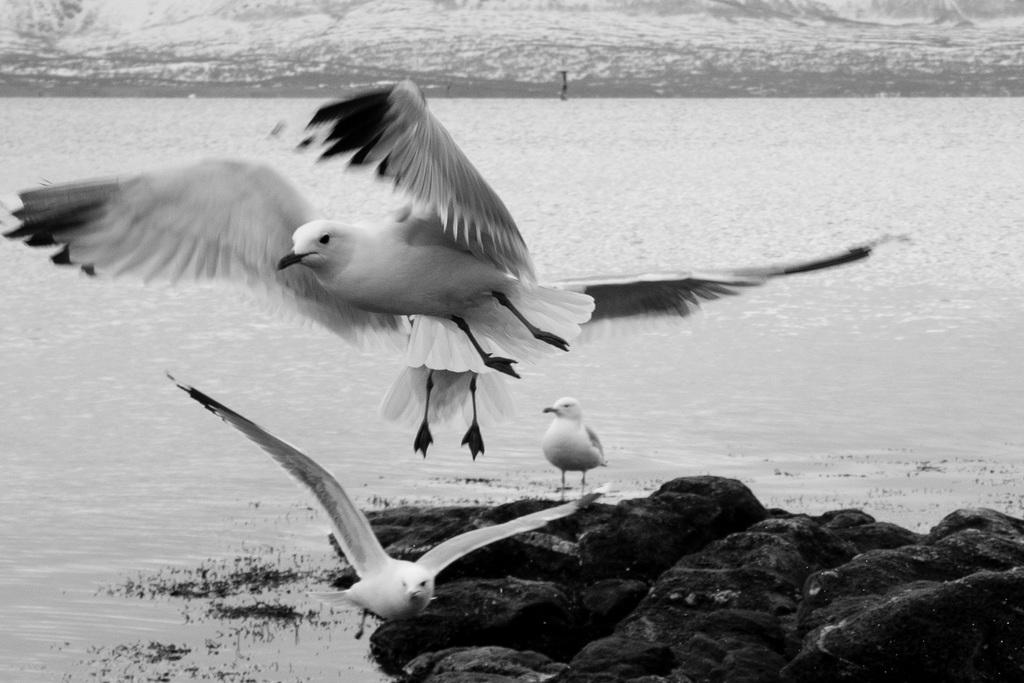What type of animals can be seen in the picture? There are birds in the picture. What physical feature do the birds have? The birds have feathers. What can be seen in the background of the picture? There is a lake in the background of the picture. What object is present in the picture? There is a rock in the picture. What type of selection process is being used by the birds in the picture? There is no indication of a selection process in the image; the birds are simply present. 